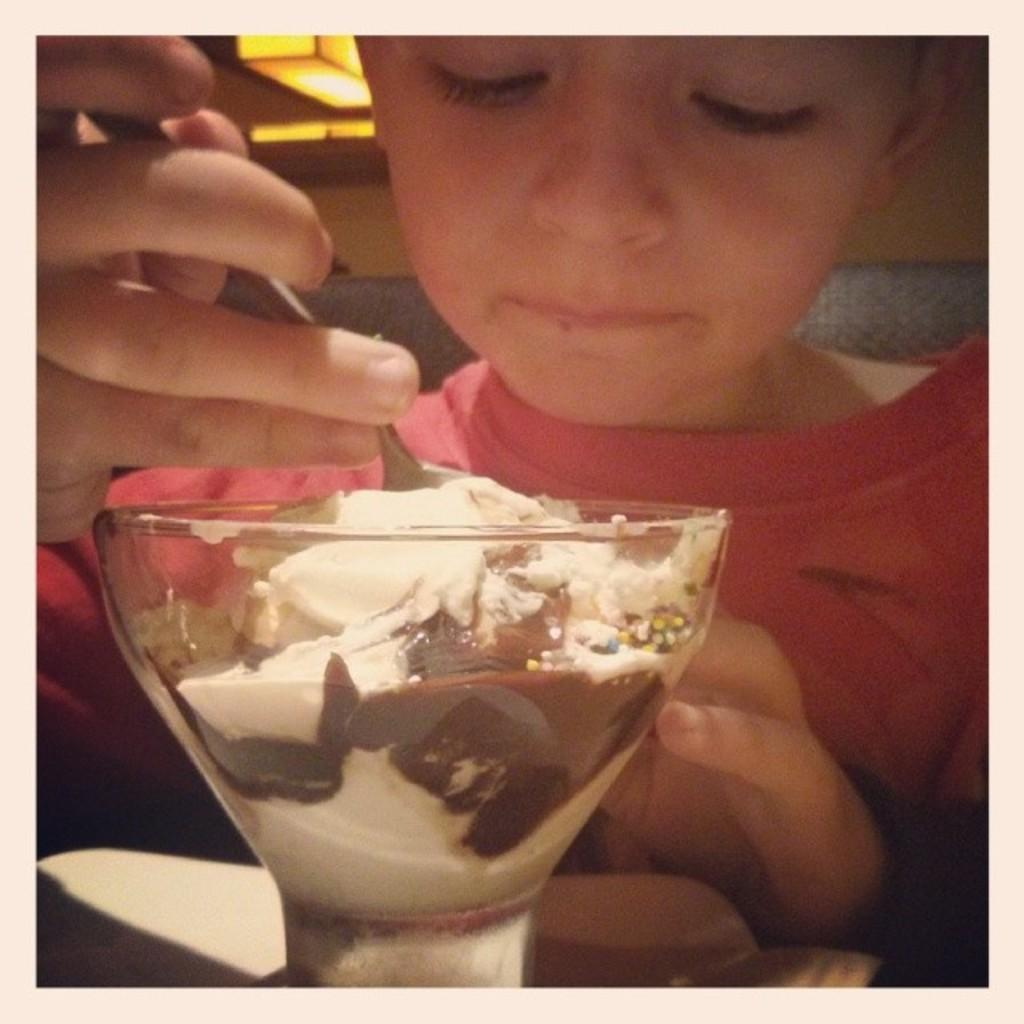Who is in the image? There is a person in the image. What is the person doing? The person is sitting and eating ice cream. What is the person holding? The person is holding a spoon. Where is the person eating ice cream? The person is eating ice cream at a table. What else can be seen in the image besides the person and the table? There are other objects present in the image. What type of harmony is the person singing in the image? There is no indication in the image that the person is singing, nor is there any mention of harmony. 